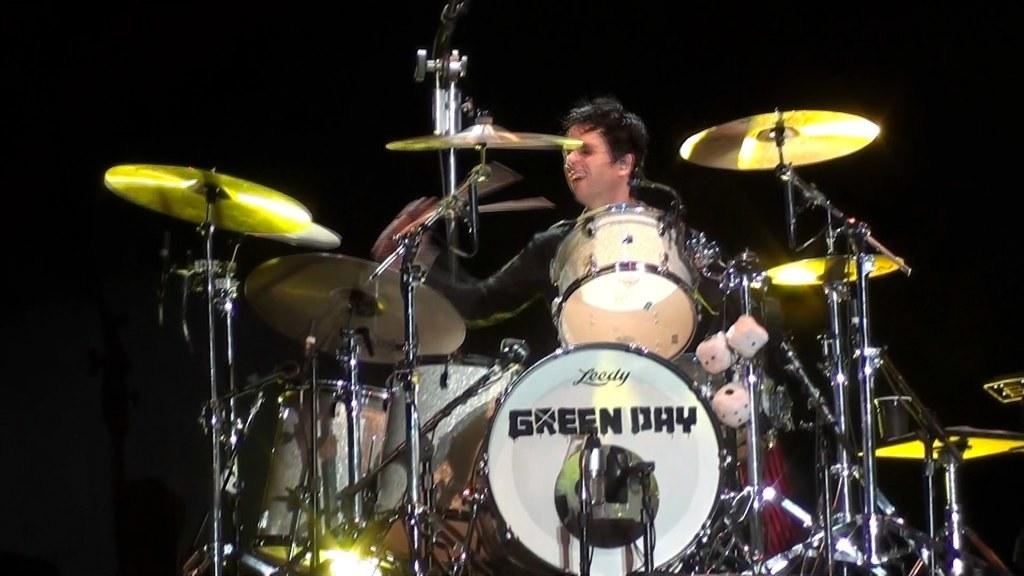What is the person in the image doing? The person is playing drums. Where are the drums located in relation to the person? The drums are in front of the person. What other object is present in front of the person? There is a microphone present in front of the person. What type of scent can be detected from the person playing drums in the image? There is no information about the scent of the person playing drums in the image. 